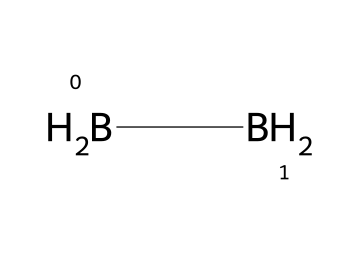How many boron atoms are present in diborane? The SMILES representation shows two [B] (boron) symbols, indicating that there are two boron atoms in the structure.
Answer: 2 What is the total number of hydrogen atoms in diborane? The SMILES structure represents four [H] (hydrogen) for the two [BH2] groups, leading to a total of four hydrogen atoms in diborane.
Answer: 4 What type of molecular arrangement does diborane exhibit? Each boron atom is connected to two hydrogen atoms, and the two boron atoms are connected to each other, making it a unique bridging structure with an overall bipyramidal arrangement.
Answer: bipyramidal Is diborane a solid, liquid, or gas at room temperature? Diborane is known to be a gas at room temperature, making it useful in various chemical applications such as air purification.
Answer: gas What family of compounds does diborane belong to? Diborane falls under the category of boranes, which are hydrides of boron.
Answer: boranes What is a key property of diborane that affects its use in air purifiers? Diborane is highly reactive and can participate in various chemical reactions, which allows it to effectively remove contaminants from the air in purification systems.
Answer: highly reactive Can diborane exist in a pure state due to its reactivity? Due to its high reactivity, diborane is typically handled in a controlled environment and generally does not exist in isolation for extended periods.
Answer: no 